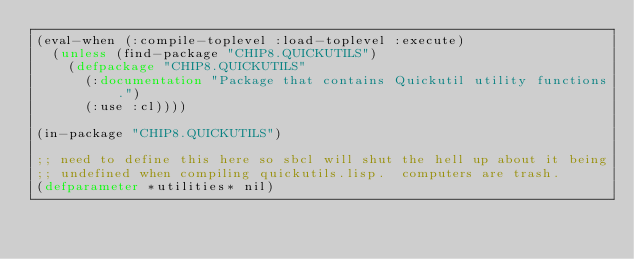<code> <loc_0><loc_0><loc_500><loc_500><_Lisp_>(eval-when (:compile-toplevel :load-toplevel :execute)
  (unless (find-package "CHIP8.QUICKUTILS")
    (defpackage "CHIP8.QUICKUTILS"
      (:documentation "Package that contains Quickutil utility functions.")
      (:use :cl))))

(in-package "CHIP8.QUICKUTILS")

;; need to define this here so sbcl will shut the hell up about it being
;; undefined when compiling quickutils.lisp.  computers are trash.
(defparameter *utilities* nil)

</code> 